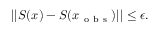Convert formula to latex. <formula><loc_0><loc_0><loc_500><loc_500>| | S ( x ) - S ( x _ { o b s } ) | | \leq \epsilon .</formula> 